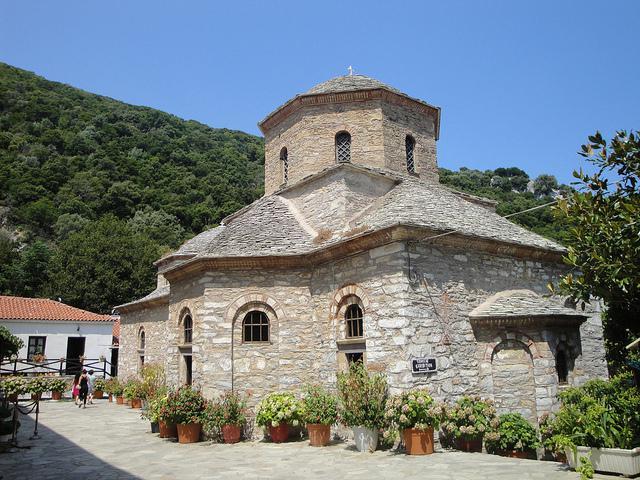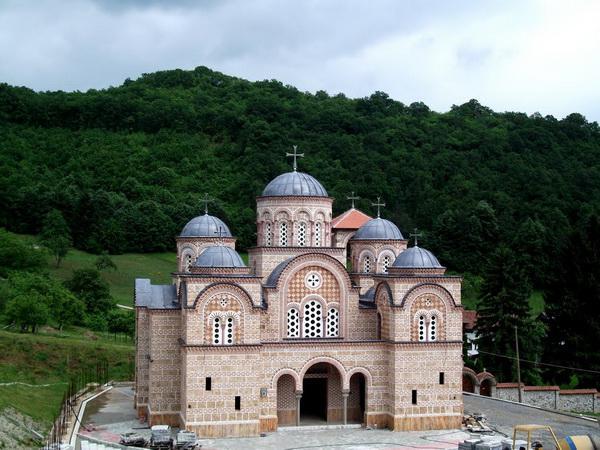The first image is the image on the left, the second image is the image on the right. Assess this claim about the two images: "One building features three arches topped by a circle over the main archway entrance.". Correct or not? Answer yes or no. Yes. 